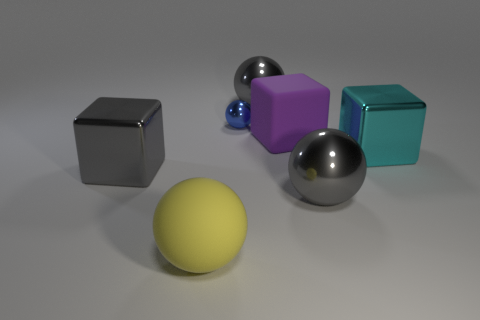Add 1 large yellow shiny objects. How many objects exist? 8 Subtract all cubes. How many objects are left? 4 Add 7 gray balls. How many gray balls are left? 9 Add 3 large rubber cubes. How many large rubber cubes exist? 4 Subtract 1 cyan blocks. How many objects are left? 6 Subtract all small gray cylinders. Subtract all large yellow rubber objects. How many objects are left? 6 